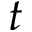Convert formula to latex. <formula><loc_0><loc_0><loc_500><loc_500>t</formula> 